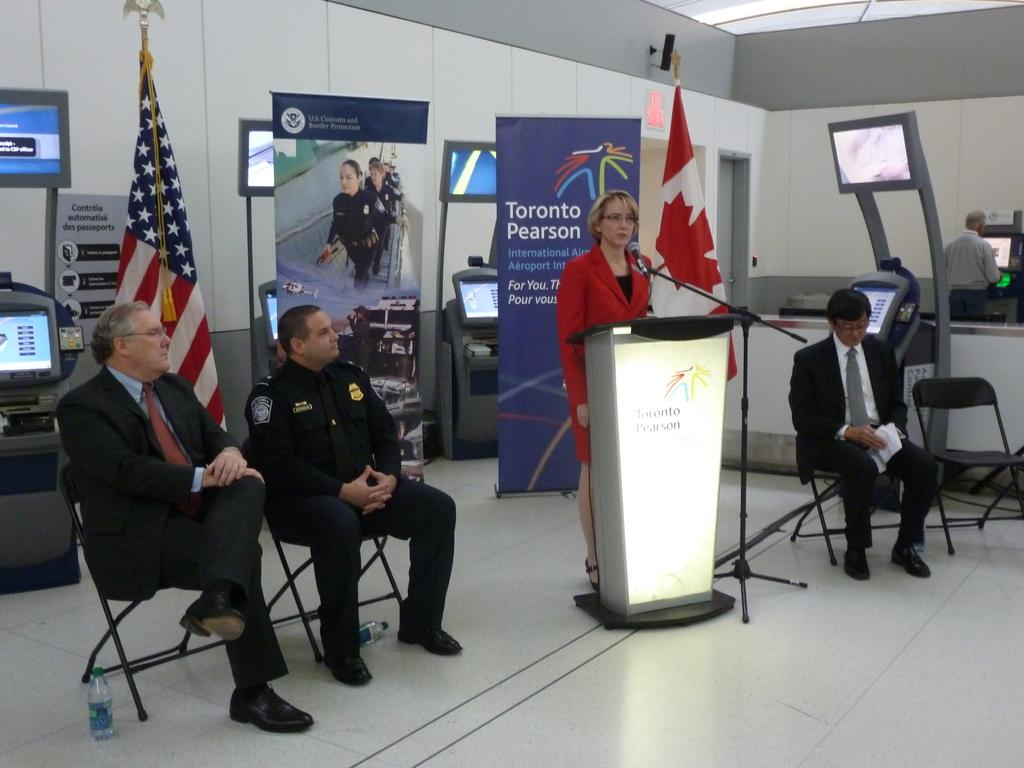<image>
Share a concise interpretation of the image provided. A woman in red stands at a podium in front of a Toronto Pearson banner. 